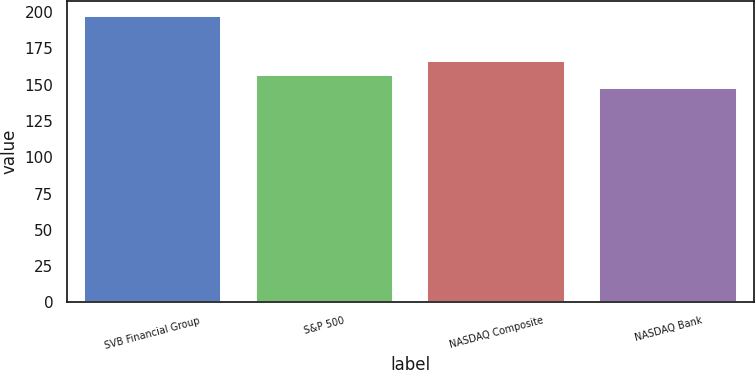Convert chart. <chart><loc_0><loc_0><loc_500><loc_500><bar_chart><fcel>SVB Financial Group<fcel>S&P 500<fcel>NASDAQ Composite<fcel>NASDAQ Bank<nl><fcel>197.66<fcel>156.82<fcel>166.19<fcel>147.41<nl></chart> 